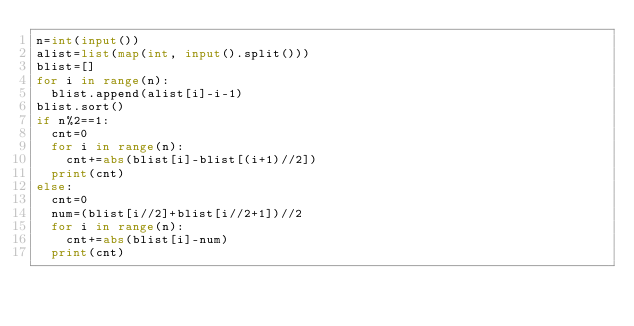<code> <loc_0><loc_0><loc_500><loc_500><_Python_>n=int(input())
alist=list(map(int, input().split()))
blist=[]
for i in range(n):
  blist.append(alist[i]-i-1)
blist.sort()
if n%2==1:
  cnt=0
  for i in range(n):
    cnt+=abs(blist[i]-blist[(i+1)//2])
  print(cnt)
else:
  cnt=0
  num=(blist[i//2]+blist[i//2+1])//2
  for i in range(n):
    cnt+=abs(blist[i]-num)
  print(cnt)</code> 